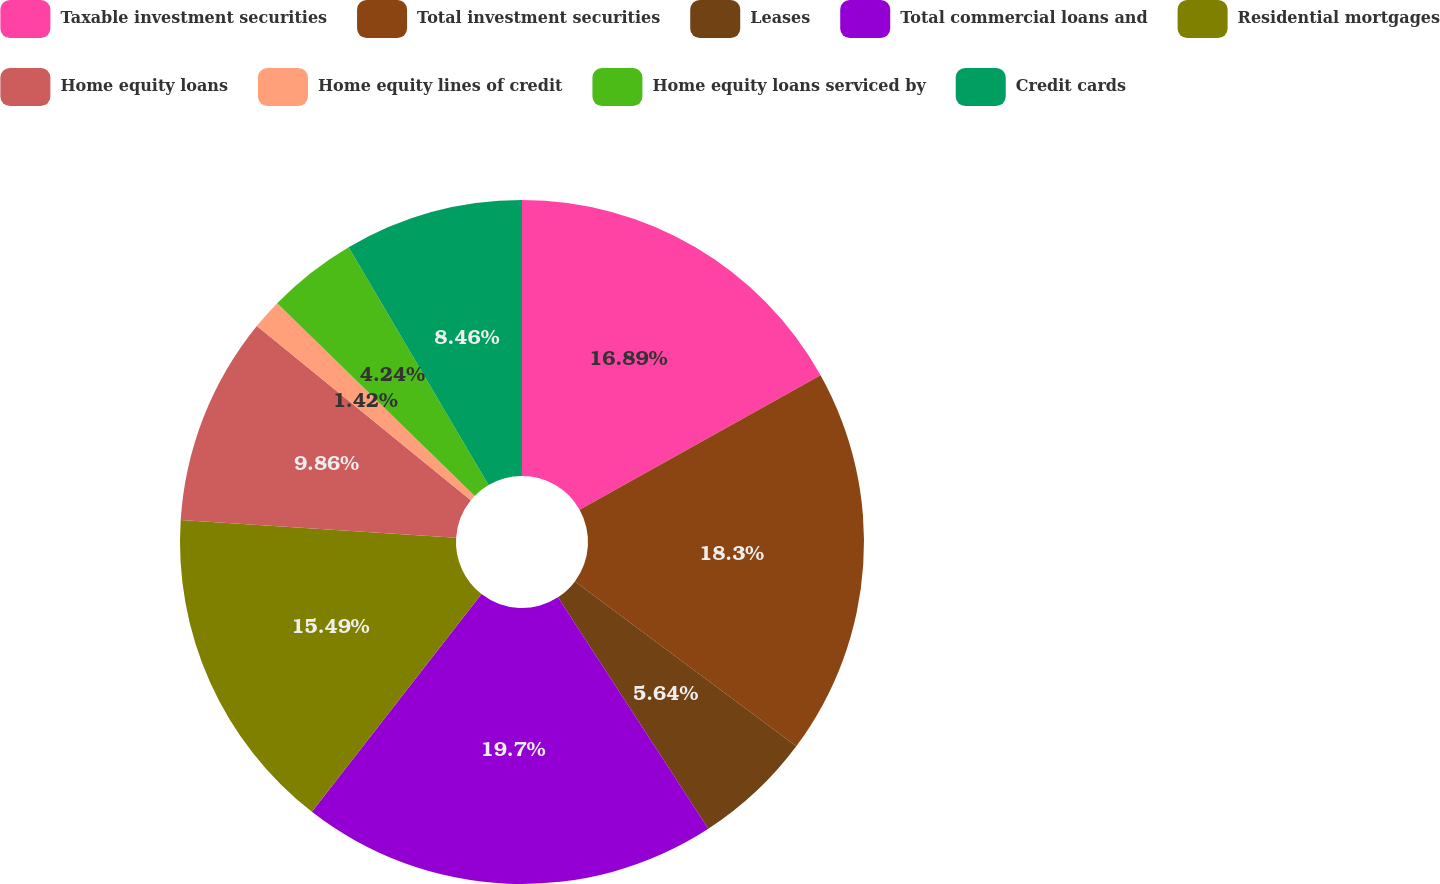Convert chart to OTSL. <chart><loc_0><loc_0><loc_500><loc_500><pie_chart><fcel>Taxable investment securities<fcel>Total investment securities<fcel>Leases<fcel>Total commercial loans and<fcel>Residential mortgages<fcel>Home equity loans<fcel>Home equity lines of credit<fcel>Home equity loans serviced by<fcel>Credit cards<nl><fcel>16.89%<fcel>18.3%<fcel>5.64%<fcel>19.7%<fcel>15.49%<fcel>9.86%<fcel>1.42%<fcel>4.24%<fcel>8.46%<nl></chart> 